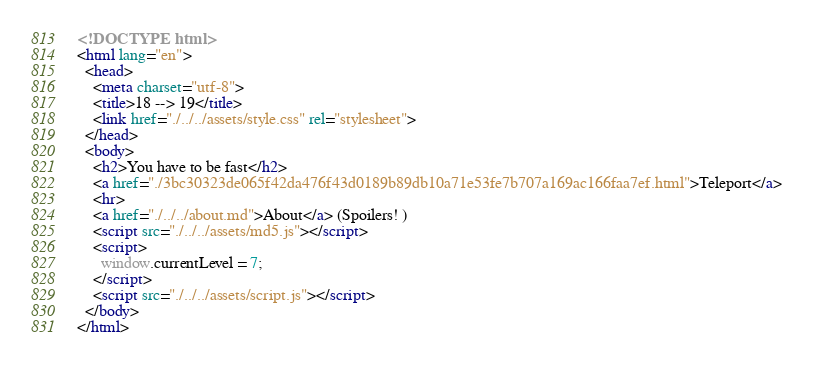Convert code to text. <code><loc_0><loc_0><loc_500><loc_500><_HTML_><!DOCTYPE html>
<html lang="en">
  <head>
    <meta charset="utf-8">
    <title>18 --> 19</title>
    <link href="./../../assets/style.css" rel="stylesheet">
  </head>
  <body>
    <h2>You have to be fast</h2>
    <a href="./3bc30323de065f42da476f43d0189b89db10a71e53fe7b707a169ac166faa7ef.html">Teleport</a>
    <hr>
    <a href="./../../about.md">About</a> (Spoilers! )
    <script src="./../../assets/md5.js"></script>
    <script>
      window.currentLevel = 7;
    </script>
    <script src="./../../assets/script.js"></script>
  </body>
</html></code> 